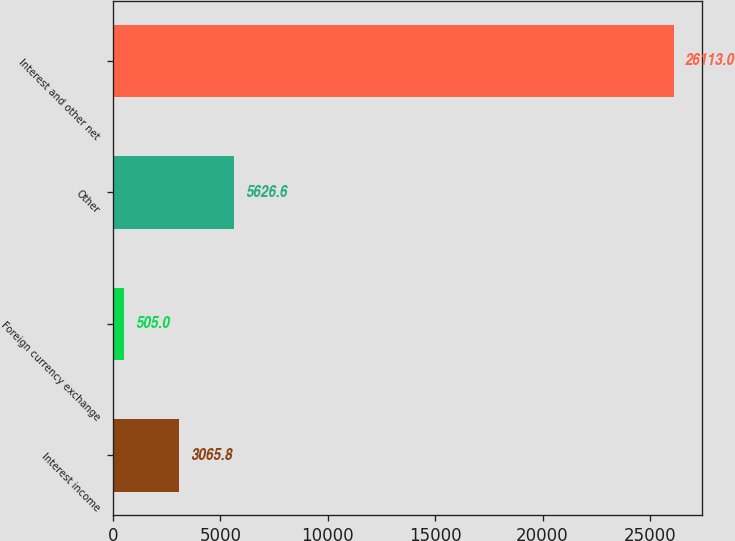<chart> <loc_0><loc_0><loc_500><loc_500><bar_chart><fcel>Interest income<fcel>Foreign currency exchange<fcel>Other<fcel>Interest and other net<nl><fcel>3065.8<fcel>505<fcel>5626.6<fcel>26113<nl></chart> 